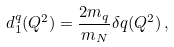<formula> <loc_0><loc_0><loc_500><loc_500>d _ { 1 } ^ { q } ( Q ^ { 2 } ) = \frac { 2 m _ { q } } { m _ { N } } \delta q ( Q ^ { 2 } ) \, ,</formula> 